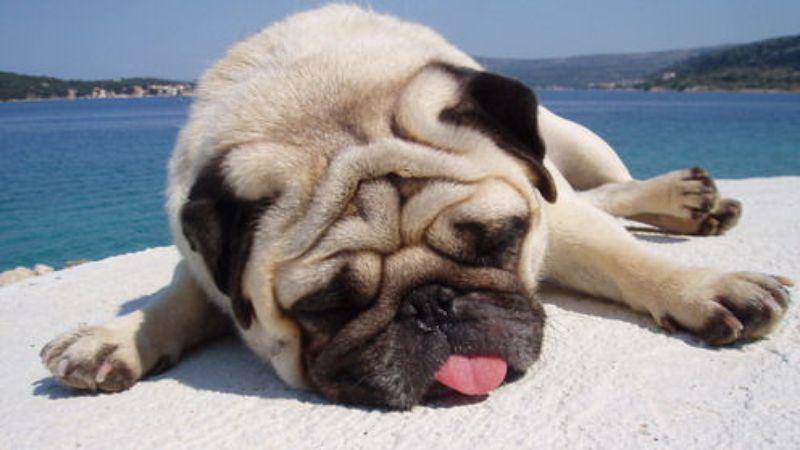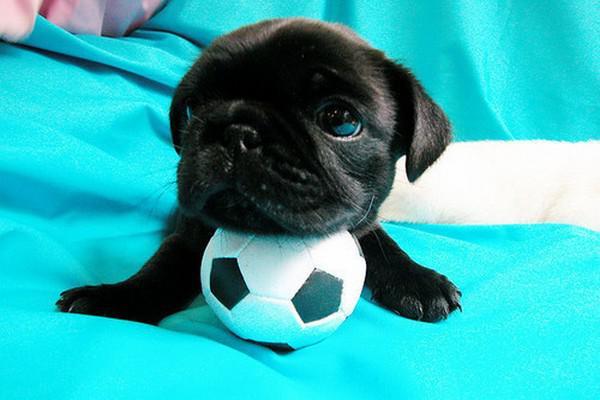The first image is the image on the left, the second image is the image on the right. Analyze the images presented: Is the assertion "In one image a dog is with a soccer ball toy." valid? Answer yes or no. Yes. The first image is the image on the left, the second image is the image on the right. Examine the images to the left and right. Is the description "The dog on the right is posing with a black and white ball" accurate? Answer yes or no. Yes. 